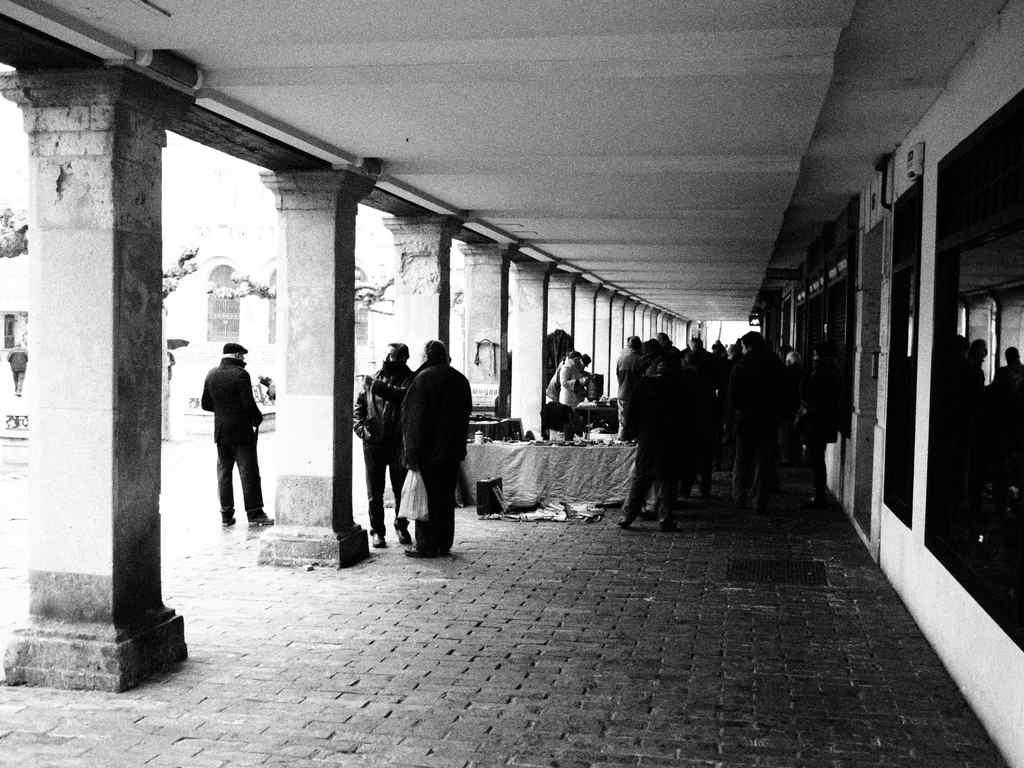What can be seen in the image? There are people, pillars, objects on tables, a wall, windows, and other objects in the image. Can you describe the setting of the image? The image features a room with tables, pillars, and a wall, along with windows and other objects. What might the people in the image be doing? It is not clear from the image what the people are doing, as their actions are not visible. What type of letter is being passed around in the image? There is no letter present in the image; it features people, pillars, objects on tables, a wall, windows, and other objects. How many guns can be seen in the image? There are no guns present in the image. 